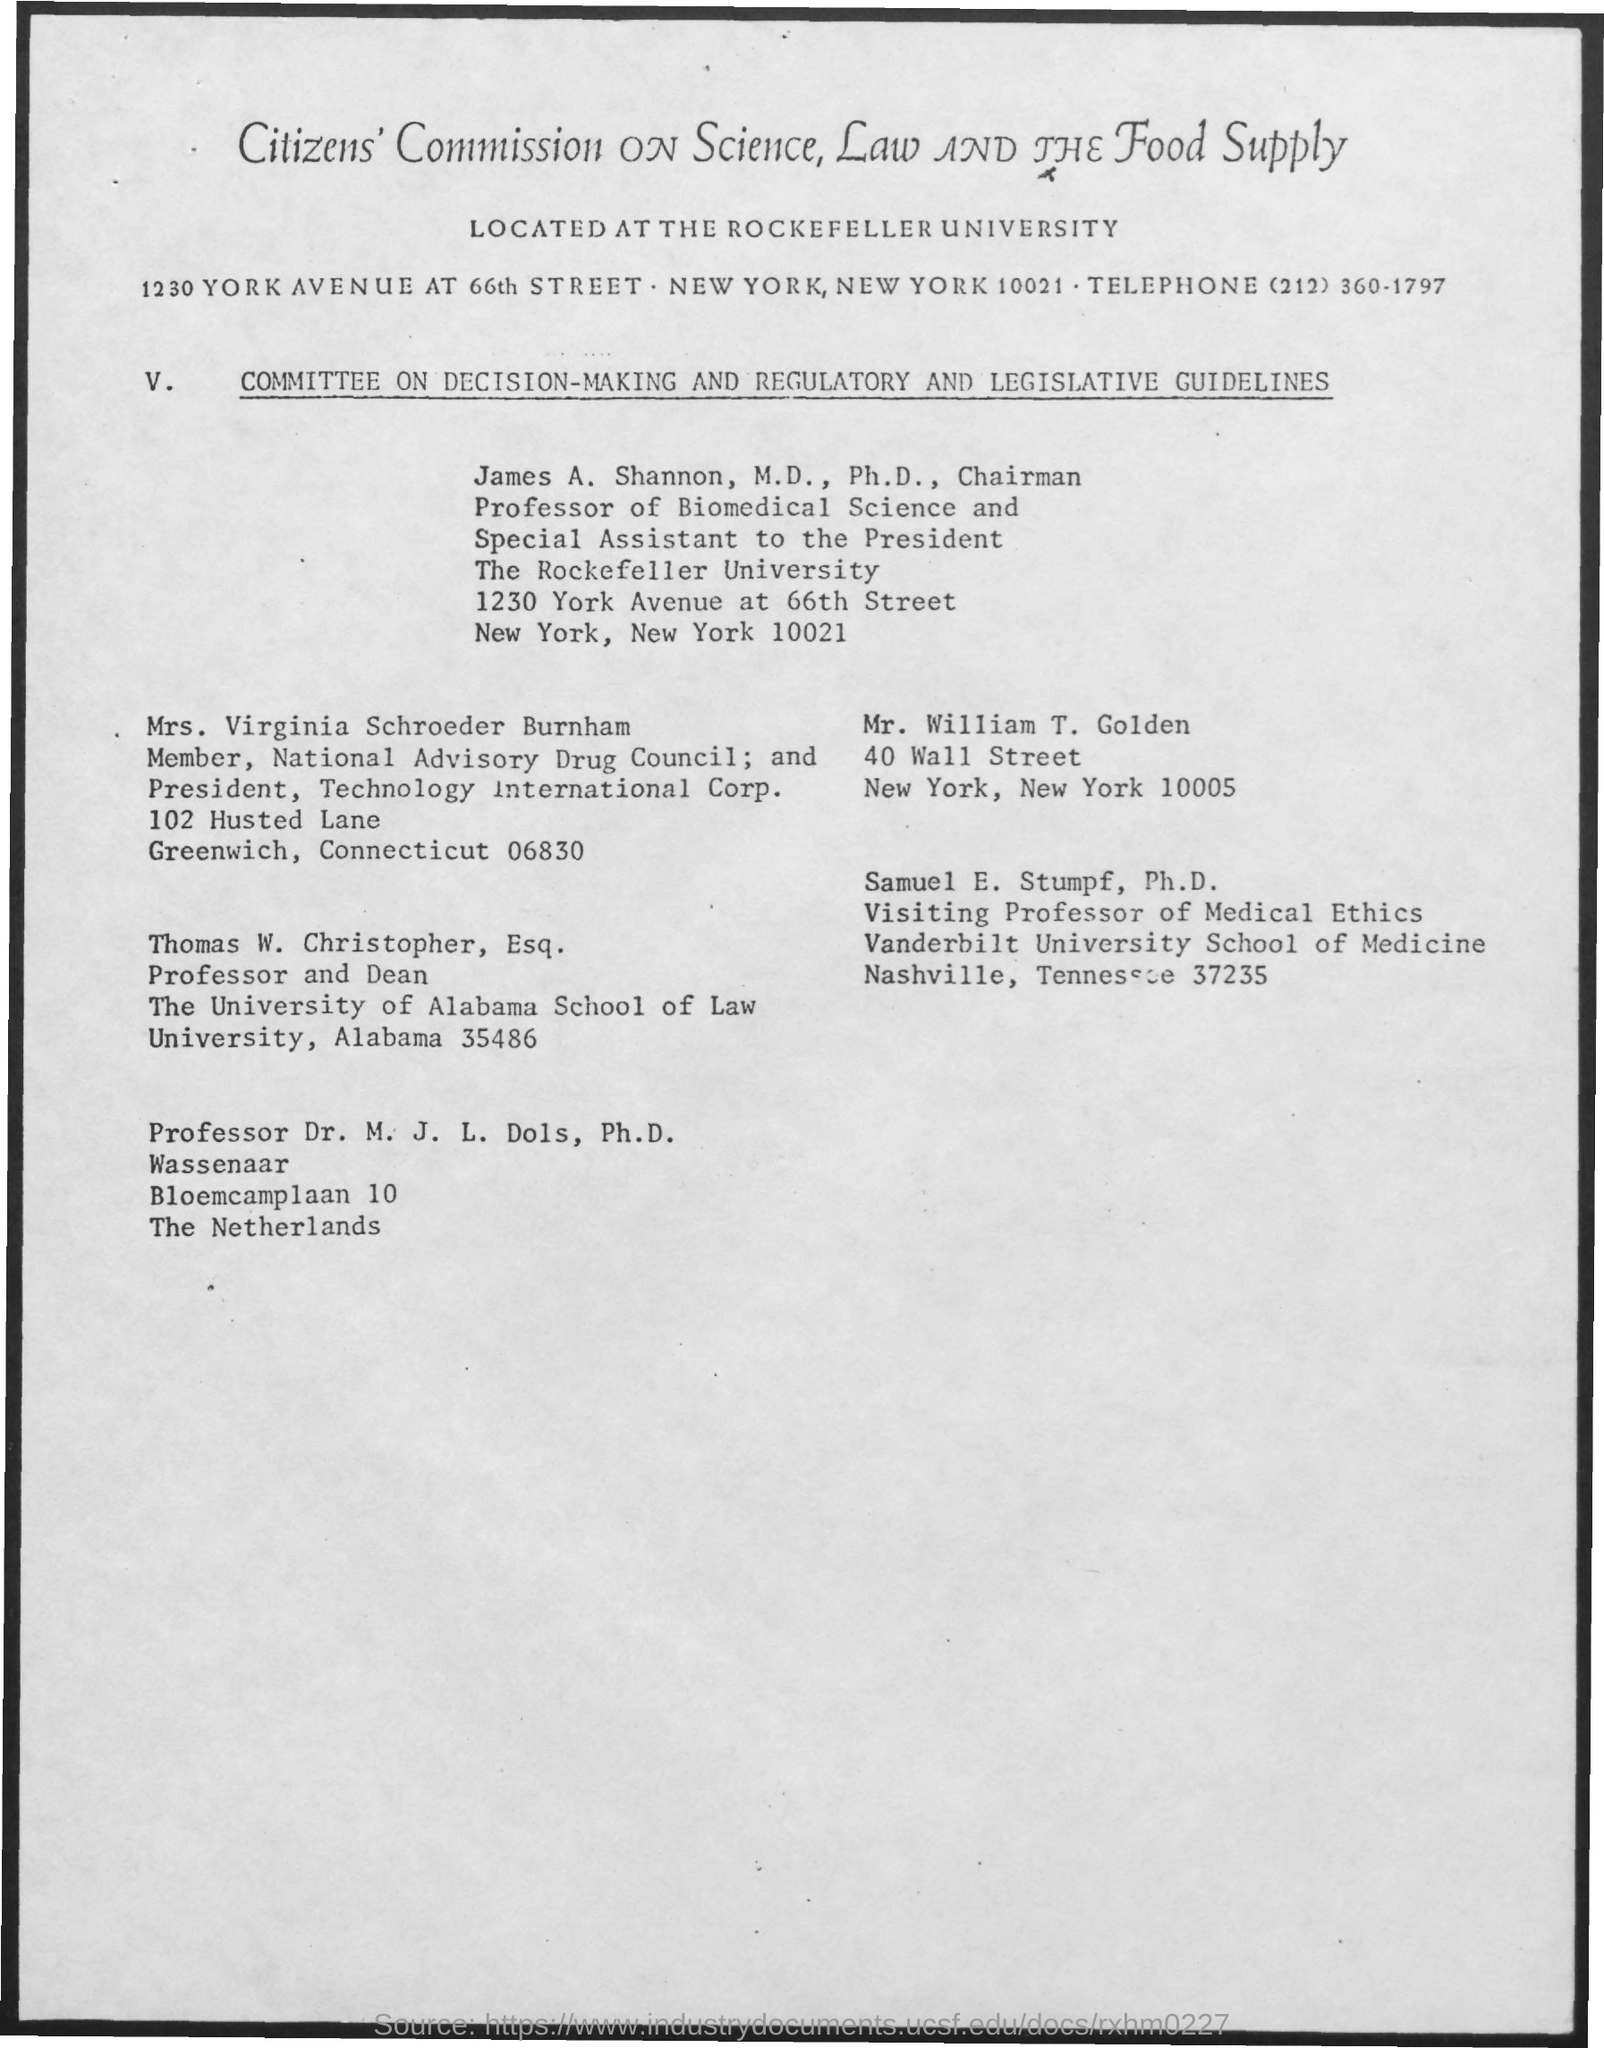Give some essential details in this illustration. The telephone number mentioned in the document is (212) 360-1797. The Citizens' Commission on science, law, and the food supply is located at Rockefeller University. 